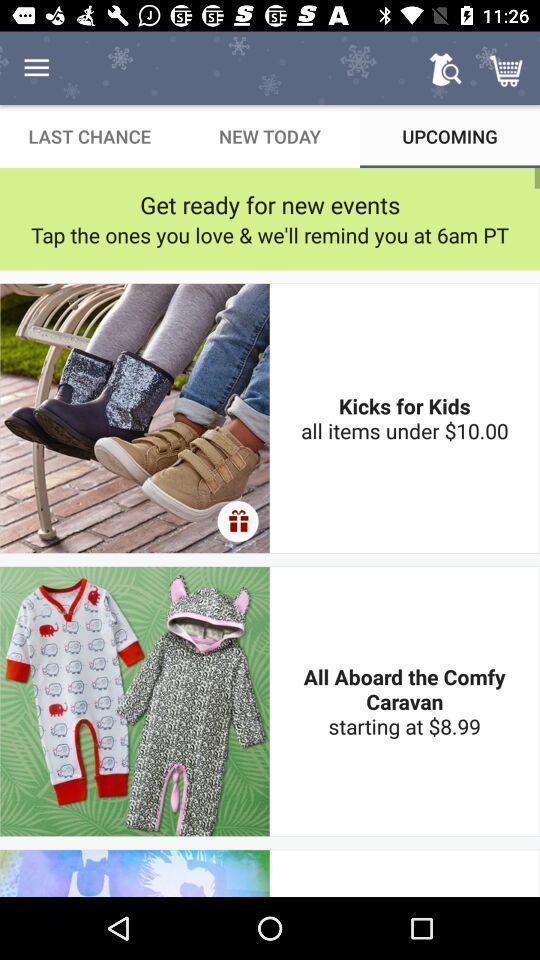Provide a description of this screenshot. Screen displaying the items in a shopping application. 